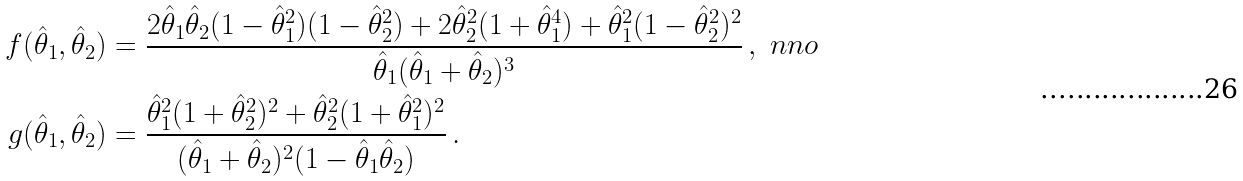Convert formula to latex. <formula><loc_0><loc_0><loc_500><loc_500>f ( \hat { \theta } _ { 1 } , \hat { \theta } _ { 2 } ) & = \frac { 2 \hat { \theta } _ { 1 } \hat { \theta } _ { 2 } ( 1 - \hat { \theta } _ { 1 } ^ { 2 } ) ( 1 - \hat { \theta } _ { 2 } ^ { 2 } ) + 2 \hat { \theta } _ { 2 } ^ { 2 } ( 1 + \hat { \theta } _ { 1 } ^ { 4 } ) + \hat { \theta } _ { 1 } ^ { 2 } ( 1 - \hat { \theta } _ { 2 } ^ { 2 } ) ^ { 2 } } { \hat { \theta } _ { 1 } ( \hat { \theta } _ { 1 } + \hat { \theta } _ { 2 } ) ^ { 3 } } \, , \ n n o \\ g ( \hat { \theta } _ { 1 } , \hat { \theta } _ { 2 } ) & = \frac { \hat { \theta } _ { 1 } ^ { 2 } ( 1 + \hat { \theta } _ { 2 } ^ { 2 } ) ^ { 2 } + \hat { \theta } _ { 2 } ^ { 2 } ( 1 + \hat { \theta } _ { 1 } ^ { 2 } ) ^ { 2 } } { ( \hat { \theta } _ { 1 } + \hat { \theta } _ { 2 } ) ^ { 2 } ( 1 - \hat { \theta } _ { 1 } \hat { \theta } _ { 2 } ) } \, .</formula> 